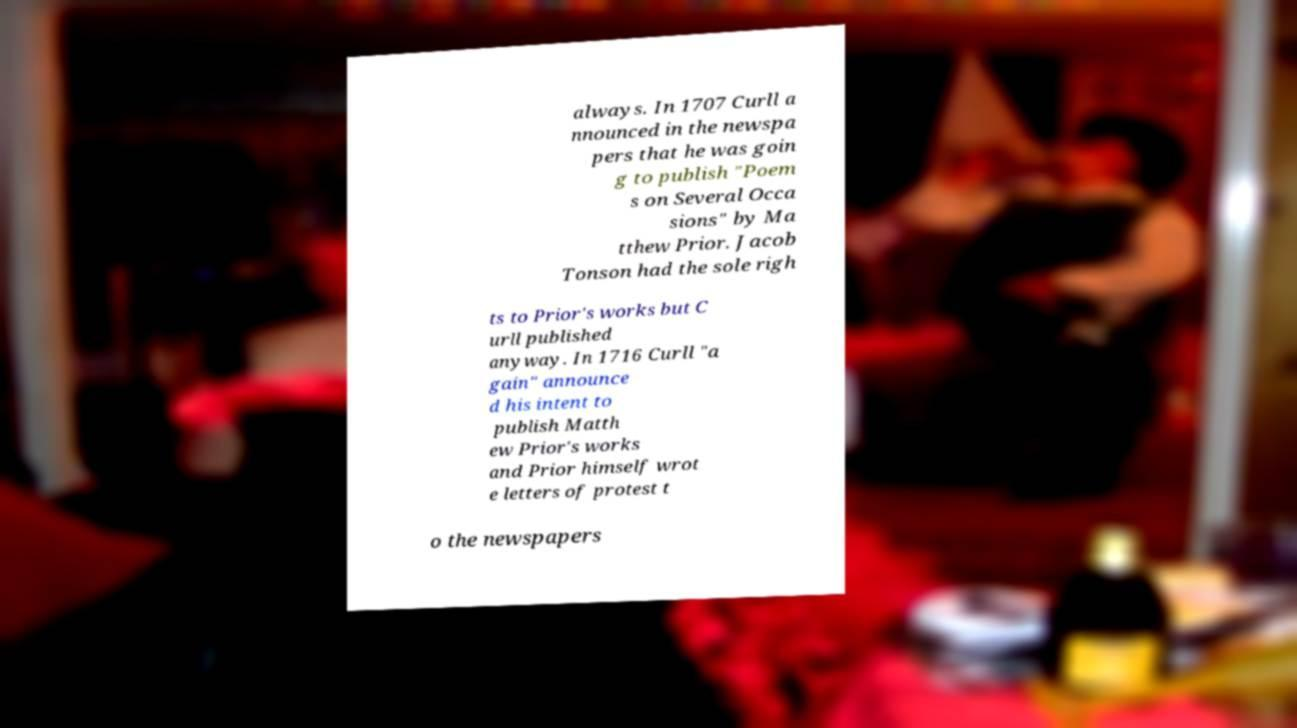Please read and relay the text visible in this image. What does it say? always. In 1707 Curll a nnounced in the newspa pers that he was goin g to publish "Poem s on Several Occa sions" by Ma tthew Prior. Jacob Tonson had the sole righ ts to Prior's works but C urll published anyway. In 1716 Curll "a gain" announce d his intent to publish Matth ew Prior's works and Prior himself wrot e letters of protest t o the newspapers 